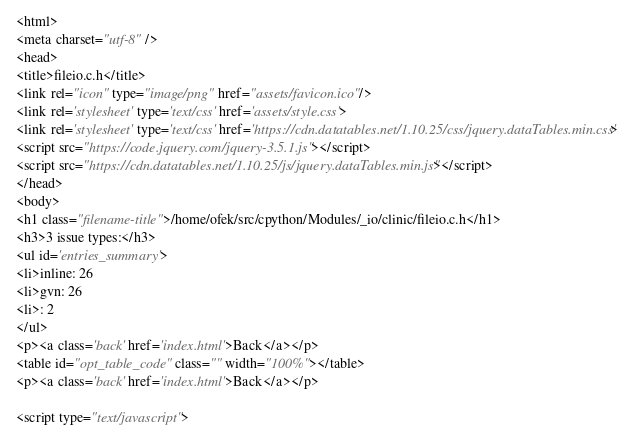<code> <loc_0><loc_0><loc_500><loc_500><_HTML_>
<html>
<meta charset="utf-8" />
<head>
<title>fileio.c.h</title>
<link rel="icon" type="image/png" href="assets/favicon.ico"/>
<link rel='stylesheet' type='text/css' href='assets/style.css'>
<link rel='stylesheet' type='text/css' href='https://cdn.datatables.net/1.10.25/css/jquery.dataTables.min.css'>
<script src="https://code.jquery.com/jquery-3.5.1.js"></script>
<script src="https://cdn.datatables.net/1.10.25/js/jquery.dataTables.min.js"></script>
</head>
<body>
<h1 class="filename-title">/home/ofek/src/cpython/Modules/_io/clinic/fileio.c.h</h1>
<h3>3 issue types:</h3>
<ul id='entries_summary'>
<li>inline: 26
<li>gvn: 26
<li>: 2
</ul>
<p><a class='back' href='index.html'>Back</a></p>
<table id="opt_table_code" class="" width="100%"></table>
<p><a class='back' href='index.html'>Back</a></p>

<script type="text/javascript"></code> 